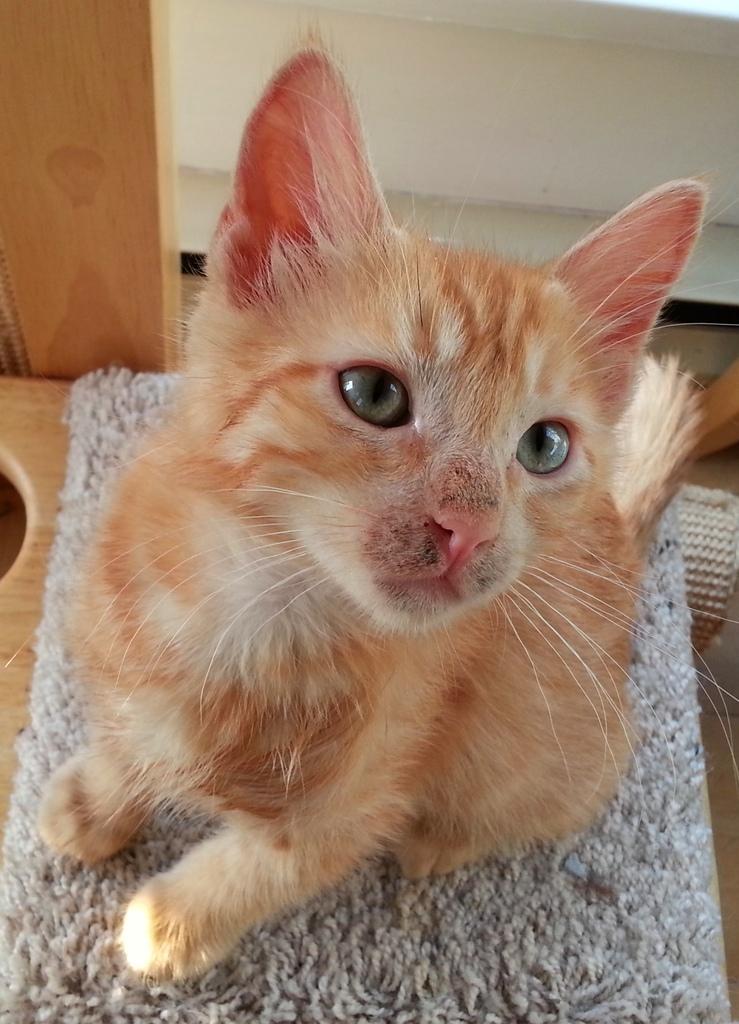Can you describe this image briefly? In this image we can see a cat on the mat, which is on the table, in the background, we can see the wall and also we can see a wooden object. 